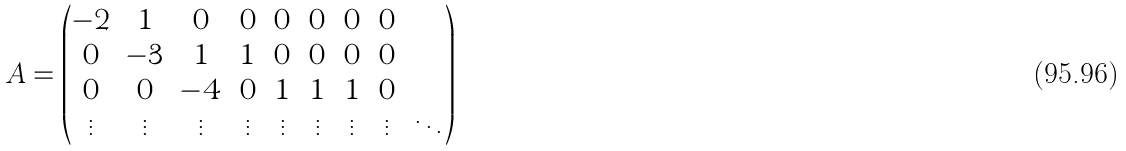<formula> <loc_0><loc_0><loc_500><loc_500>A = \begin{pmatrix} - 2 & 1 & 0 & 0 & 0 & 0 & 0 & 0 & \cdots \\ 0 & - 3 & 1 & 1 & 0 & 0 & 0 & 0 & \cdots \\ 0 & 0 & - 4 & 0 & 1 & 1 & 1 & 0 & \cdots \\ \vdots & \vdots & \vdots & \vdots & \vdots & \vdots & \vdots & \vdots & \ddots \end{pmatrix}</formula> 